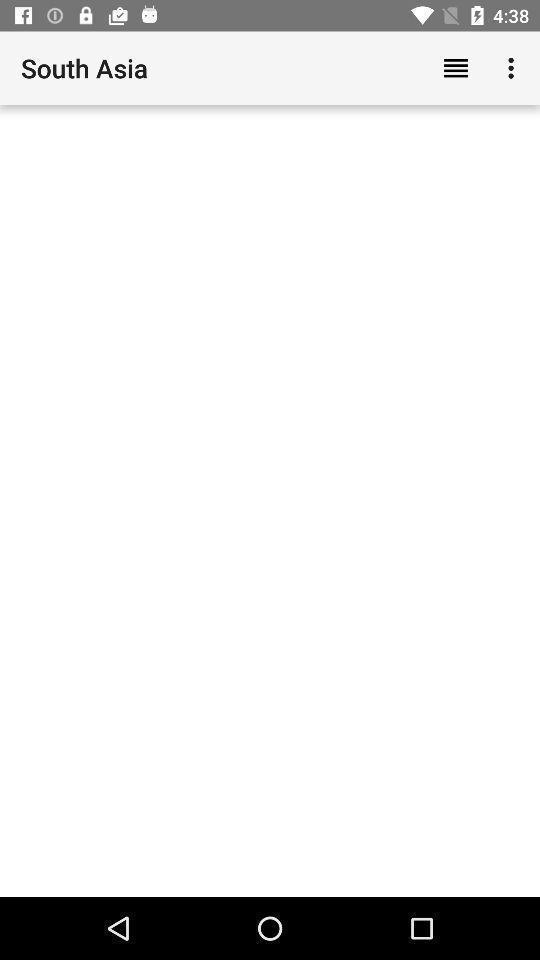What can you discern from this picture? World news for a zone on an news reading app. 